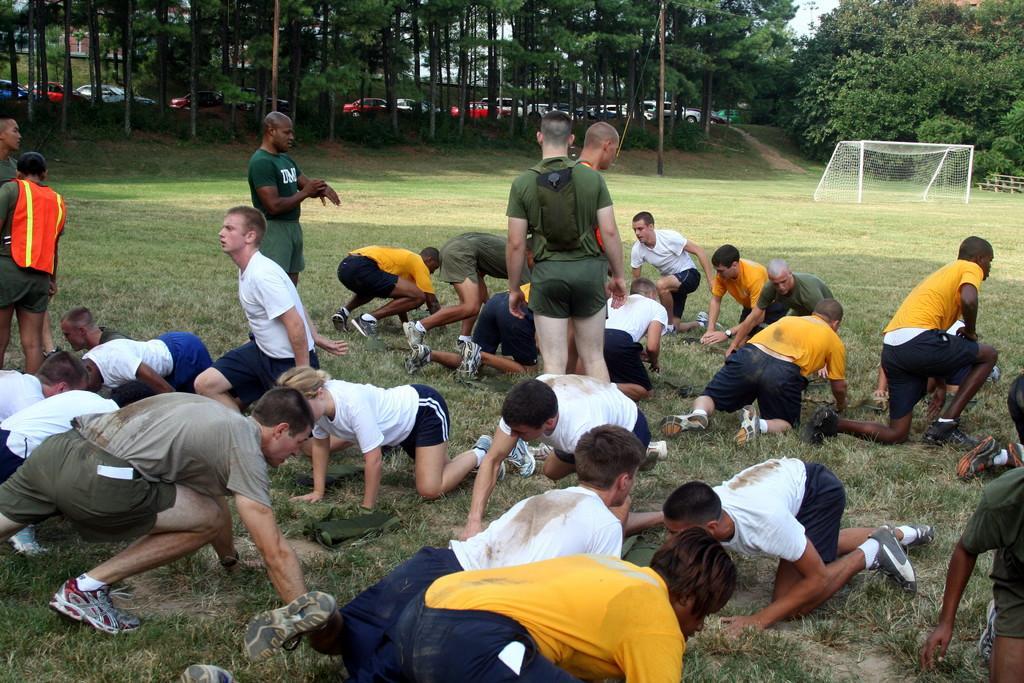Please provide a concise description of this image. In this image I can see an open grass ground and on it I can see number of people. I can see most of them are wearing white dress, few of them are wearing yellow dress and few are wearing green. In background I can see a goal post, number of trees and number of vehicles. 